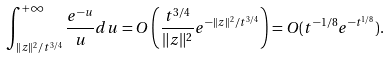Convert formula to latex. <formula><loc_0><loc_0><loc_500><loc_500>\int _ { \| z \| ^ { 2 } / t ^ { 3 / 4 } } ^ { + \infty } \frac { e ^ { - u } } { u } d u = O \left ( \frac { t ^ { 3 / 4 } } { \| z \| ^ { 2 } } e ^ { - \| z \| ^ { 2 } / t ^ { 3 / 4 } } \right ) = O ( t ^ { - 1 / 8 } e ^ { - t ^ { 1 / 8 } } ) .</formula> 